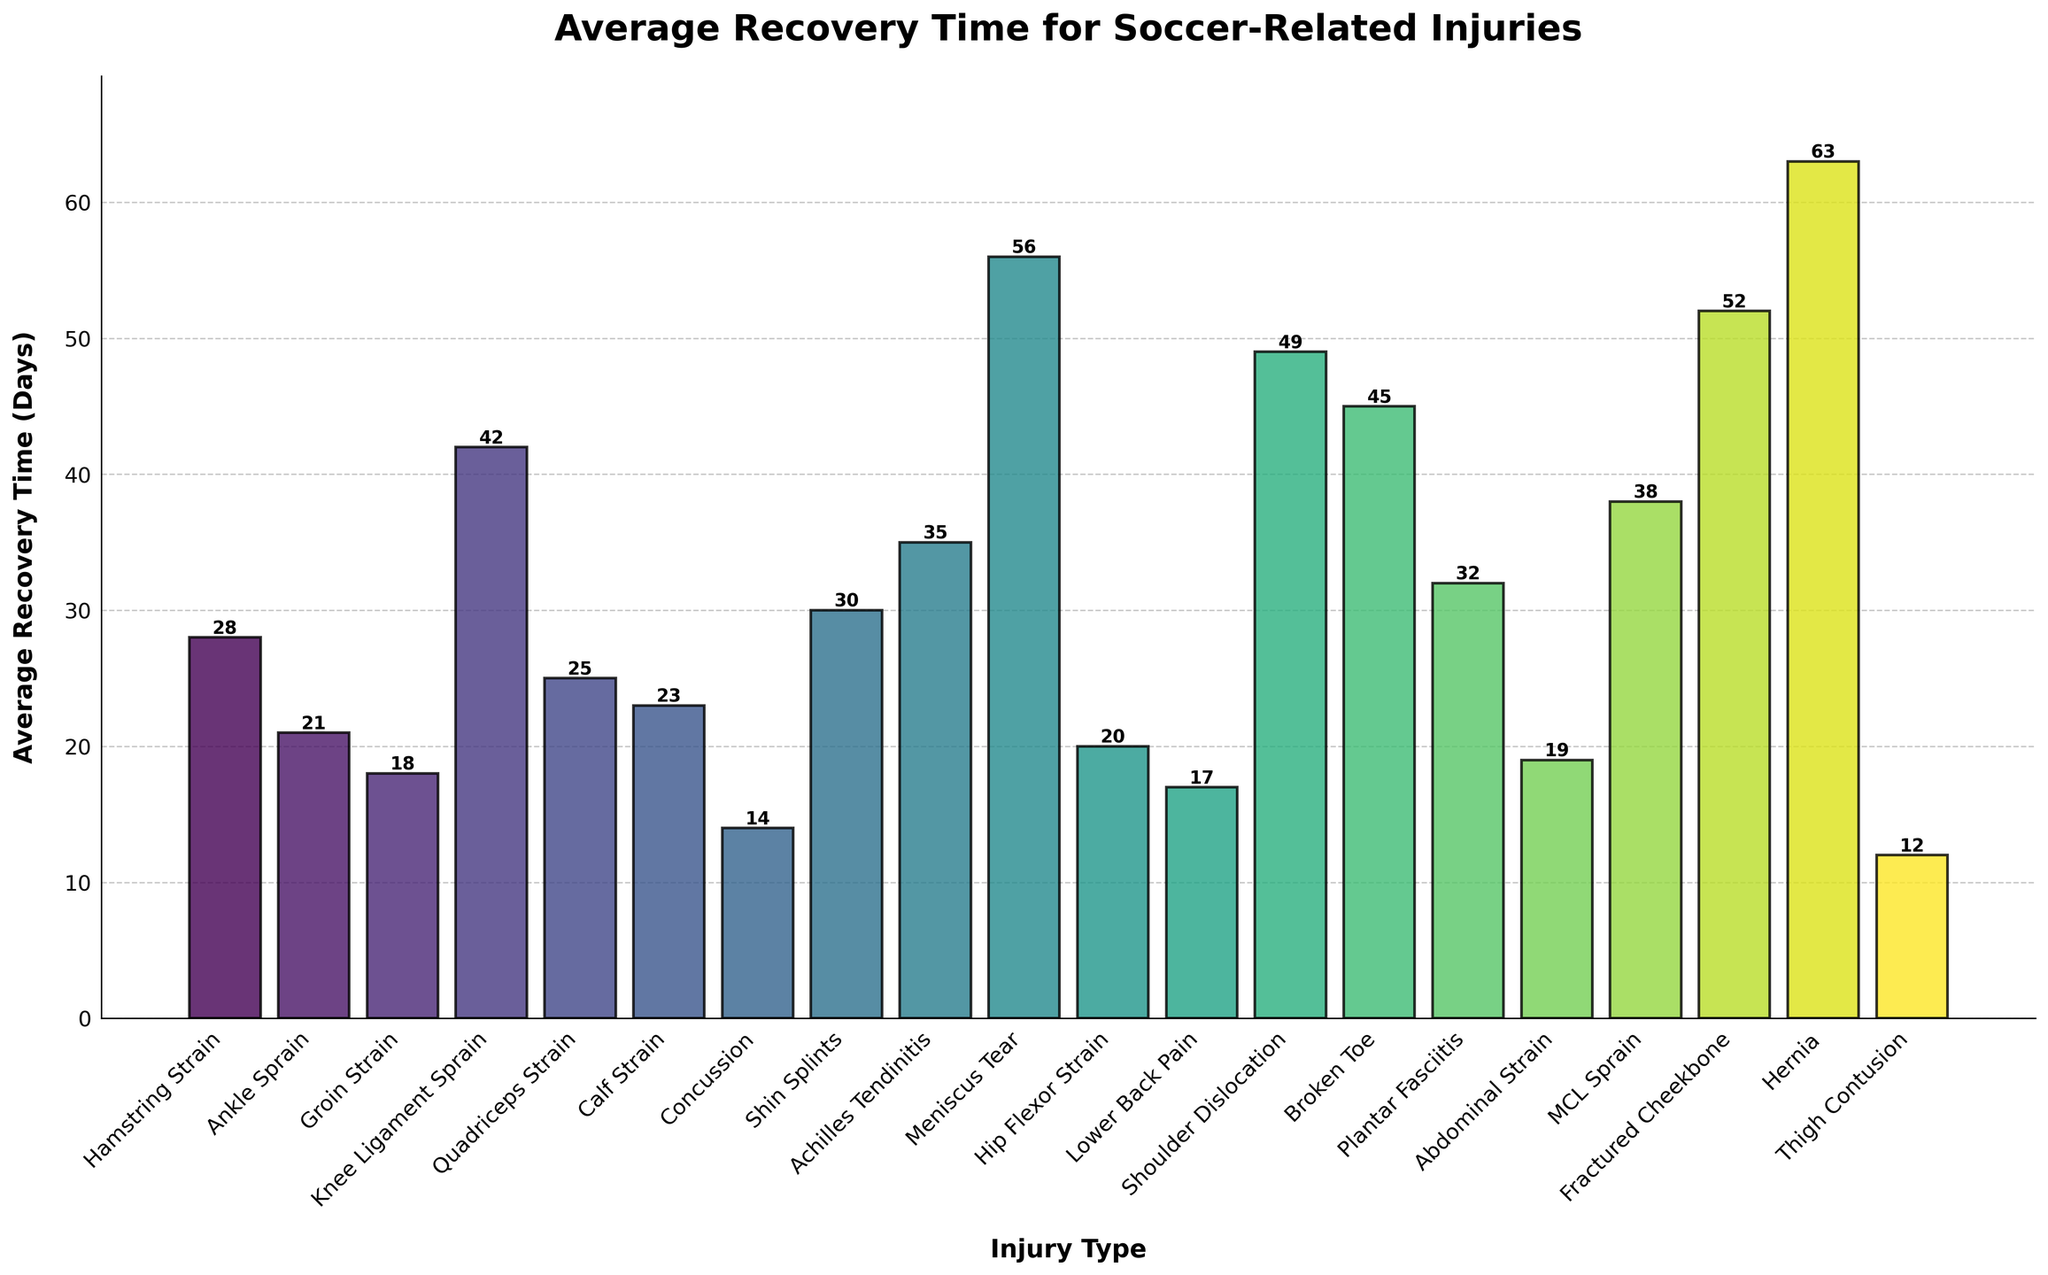Which injury type has the longest average recovery time? Examine the heights of the bars and identify the tallest one, which corresponds to the injury type with the longest recovery time. In this case, the tallest bar is for Hernia.
Answer: Hernia Which injury type has the shortest average recovery time? Inspect the heights of the bars and identify the shortest one, which corresponds to the injury type with the shortest recovery time. In this case, the shortest bar is for Thigh Contusion.
Answer: Thigh Contusion What is the difference in average recovery time between a Meniscus Tear and a Groin Strain? Find the bars corresponding to Meniscus Tear and Groin Strain and note their heights, which are 56 days and 18 days respectively. Subtract the recovery time of Groin Strain from that of Meniscus Tear (56 - 18).
Answer: 38 days Which injury requires more recovery time, a Broken Toe or a Shoulder Dislocation? Compare the heights of the bars for Broken Toe and Shoulder Dislocation. The bar for Shoulder Dislocation is taller than that for Broken Toe.
Answer: Shoulder Dislocation What is the total recovery time for a Hamstring Strain, Ankle Sprain, and Groin Strain? Find the bars for Hamstring Strain (28 days), Ankle Sprain (21 days), and Groin Strain (18 days). Sum these recovery times (28 + 21 + 18).
Answer: 67 days Which injury type has a recovery time closest to one month? Identify the height of bars that are approximately 30 days. The bar for Shin Splints has an average recovery time of 30 days.
Answer: Shin Splints List all injury types with average recovery times longer than 40 days. Identify all bars that extend beyond the 40-day mark: Knee Ligament Sprain (42 days), Meniscus Tear (56 days), Shoulder Dislocation (49 days), Broken Toe (45 days), Fractured Cheekbone (52 days), and Hernia (63 days).
Answer: Knee Ligament Sprain, Meniscus Tear, Shoulder Dislocation, Broken Toe, Fractured Cheekbone, Hernia How much longer is the recovery for Achilles Tendinitis compared to a Concussion? Determine the heights of the bars for Achilles Tendinitis (35 days) and Concussion (14 days). Subtract the recovery time of Concussion from that of Achilles Tendinitis (35 - 14).
Answer: 21 days Is the average recovery time for an MCL Sprain greater than for a Calf Strain? Compare the heights of the bars for MCL Sprain (38 days) and Calf Strain (23 days). The bar for MCL Sprain is taller.
Answer: Yes 